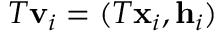<formula> <loc_0><loc_0><loc_500><loc_500>T v _ { i } = ( T x _ { i } , h _ { i } )</formula> 